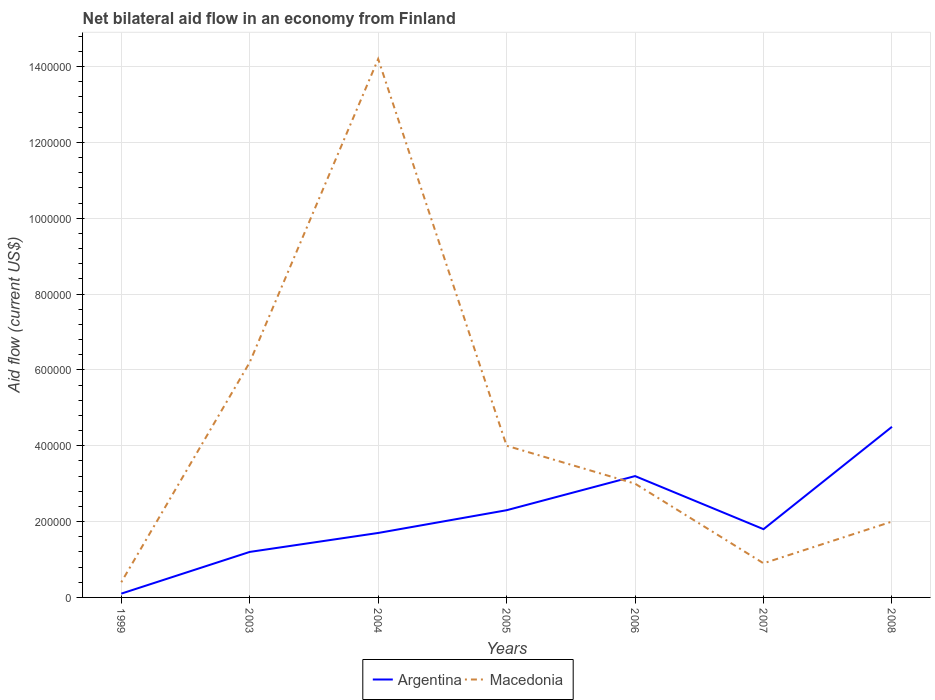How many different coloured lines are there?
Provide a succinct answer. 2. What is the total net bilateral aid flow in Argentina in the graph?
Provide a short and direct response. -3.10e+05. How many years are there in the graph?
Offer a very short reply. 7. Are the values on the major ticks of Y-axis written in scientific E-notation?
Provide a succinct answer. No. How many legend labels are there?
Offer a terse response. 2. What is the title of the graph?
Give a very brief answer. Net bilateral aid flow in an economy from Finland. What is the Aid flow (current US$) in Argentina in 1999?
Make the answer very short. 10000. What is the Aid flow (current US$) in Macedonia in 2003?
Offer a very short reply. 6.20e+05. What is the Aid flow (current US$) in Argentina in 2004?
Give a very brief answer. 1.70e+05. What is the Aid flow (current US$) in Macedonia in 2004?
Provide a short and direct response. 1.42e+06. What is the Aid flow (current US$) in Argentina in 2006?
Offer a very short reply. 3.20e+05. What is the Aid flow (current US$) of Macedonia in 2006?
Ensure brevity in your answer.  3.00e+05. What is the Aid flow (current US$) of Argentina in 2008?
Keep it short and to the point. 4.50e+05. What is the Aid flow (current US$) of Macedonia in 2008?
Provide a succinct answer. 2.00e+05. Across all years, what is the maximum Aid flow (current US$) in Macedonia?
Ensure brevity in your answer.  1.42e+06. Across all years, what is the minimum Aid flow (current US$) in Macedonia?
Keep it short and to the point. 4.00e+04. What is the total Aid flow (current US$) in Argentina in the graph?
Your answer should be compact. 1.48e+06. What is the total Aid flow (current US$) in Macedonia in the graph?
Give a very brief answer. 3.07e+06. What is the difference between the Aid flow (current US$) in Argentina in 1999 and that in 2003?
Provide a succinct answer. -1.10e+05. What is the difference between the Aid flow (current US$) in Macedonia in 1999 and that in 2003?
Provide a succinct answer. -5.80e+05. What is the difference between the Aid flow (current US$) of Argentina in 1999 and that in 2004?
Provide a short and direct response. -1.60e+05. What is the difference between the Aid flow (current US$) in Macedonia in 1999 and that in 2004?
Keep it short and to the point. -1.38e+06. What is the difference between the Aid flow (current US$) in Macedonia in 1999 and that in 2005?
Offer a terse response. -3.60e+05. What is the difference between the Aid flow (current US$) of Argentina in 1999 and that in 2006?
Your response must be concise. -3.10e+05. What is the difference between the Aid flow (current US$) in Macedonia in 1999 and that in 2007?
Give a very brief answer. -5.00e+04. What is the difference between the Aid flow (current US$) in Argentina in 1999 and that in 2008?
Give a very brief answer. -4.40e+05. What is the difference between the Aid flow (current US$) in Argentina in 2003 and that in 2004?
Keep it short and to the point. -5.00e+04. What is the difference between the Aid flow (current US$) of Macedonia in 2003 and that in 2004?
Give a very brief answer. -8.00e+05. What is the difference between the Aid flow (current US$) of Argentina in 2003 and that in 2005?
Provide a succinct answer. -1.10e+05. What is the difference between the Aid flow (current US$) of Macedonia in 2003 and that in 2005?
Ensure brevity in your answer.  2.20e+05. What is the difference between the Aid flow (current US$) of Argentina in 2003 and that in 2006?
Give a very brief answer. -2.00e+05. What is the difference between the Aid flow (current US$) of Macedonia in 2003 and that in 2006?
Offer a terse response. 3.20e+05. What is the difference between the Aid flow (current US$) in Macedonia in 2003 and that in 2007?
Your answer should be compact. 5.30e+05. What is the difference between the Aid flow (current US$) of Argentina in 2003 and that in 2008?
Make the answer very short. -3.30e+05. What is the difference between the Aid flow (current US$) of Argentina in 2004 and that in 2005?
Provide a short and direct response. -6.00e+04. What is the difference between the Aid flow (current US$) of Macedonia in 2004 and that in 2005?
Give a very brief answer. 1.02e+06. What is the difference between the Aid flow (current US$) in Argentina in 2004 and that in 2006?
Your response must be concise. -1.50e+05. What is the difference between the Aid flow (current US$) in Macedonia in 2004 and that in 2006?
Give a very brief answer. 1.12e+06. What is the difference between the Aid flow (current US$) in Macedonia in 2004 and that in 2007?
Give a very brief answer. 1.33e+06. What is the difference between the Aid flow (current US$) in Argentina in 2004 and that in 2008?
Keep it short and to the point. -2.80e+05. What is the difference between the Aid flow (current US$) of Macedonia in 2004 and that in 2008?
Offer a terse response. 1.22e+06. What is the difference between the Aid flow (current US$) in Argentina in 2005 and that in 2006?
Offer a terse response. -9.00e+04. What is the difference between the Aid flow (current US$) of Macedonia in 2005 and that in 2006?
Ensure brevity in your answer.  1.00e+05. What is the difference between the Aid flow (current US$) in Argentina in 2005 and that in 2008?
Your response must be concise. -2.20e+05. What is the difference between the Aid flow (current US$) in Macedonia in 2006 and that in 2008?
Make the answer very short. 1.00e+05. What is the difference between the Aid flow (current US$) of Argentina in 2007 and that in 2008?
Give a very brief answer. -2.70e+05. What is the difference between the Aid flow (current US$) in Macedonia in 2007 and that in 2008?
Give a very brief answer. -1.10e+05. What is the difference between the Aid flow (current US$) in Argentina in 1999 and the Aid flow (current US$) in Macedonia in 2003?
Keep it short and to the point. -6.10e+05. What is the difference between the Aid flow (current US$) of Argentina in 1999 and the Aid flow (current US$) of Macedonia in 2004?
Give a very brief answer. -1.41e+06. What is the difference between the Aid flow (current US$) of Argentina in 1999 and the Aid flow (current US$) of Macedonia in 2005?
Make the answer very short. -3.90e+05. What is the difference between the Aid flow (current US$) of Argentina in 1999 and the Aid flow (current US$) of Macedonia in 2007?
Offer a terse response. -8.00e+04. What is the difference between the Aid flow (current US$) of Argentina in 2003 and the Aid flow (current US$) of Macedonia in 2004?
Give a very brief answer. -1.30e+06. What is the difference between the Aid flow (current US$) of Argentina in 2003 and the Aid flow (current US$) of Macedonia in 2005?
Offer a terse response. -2.80e+05. What is the difference between the Aid flow (current US$) in Argentina in 2003 and the Aid flow (current US$) in Macedonia in 2008?
Your answer should be very brief. -8.00e+04. What is the difference between the Aid flow (current US$) in Argentina in 2004 and the Aid flow (current US$) in Macedonia in 2005?
Keep it short and to the point. -2.30e+05. What is the difference between the Aid flow (current US$) of Argentina in 2004 and the Aid flow (current US$) of Macedonia in 2007?
Offer a very short reply. 8.00e+04. What is the difference between the Aid flow (current US$) of Argentina in 2005 and the Aid flow (current US$) of Macedonia in 2007?
Make the answer very short. 1.40e+05. What is the difference between the Aid flow (current US$) of Argentina in 2006 and the Aid flow (current US$) of Macedonia in 2008?
Give a very brief answer. 1.20e+05. What is the average Aid flow (current US$) in Argentina per year?
Make the answer very short. 2.11e+05. What is the average Aid flow (current US$) in Macedonia per year?
Give a very brief answer. 4.39e+05. In the year 1999, what is the difference between the Aid flow (current US$) of Argentina and Aid flow (current US$) of Macedonia?
Your answer should be compact. -3.00e+04. In the year 2003, what is the difference between the Aid flow (current US$) in Argentina and Aid flow (current US$) in Macedonia?
Make the answer very short. -5.00e+05. In the year 2004, what is the difference between the Aid flow (current US$) in Argentina and Aid flow (current US$) in Macedonia?
Offer a very short reply. -1.25e+06. In the year 2005, what is the difference between the Aid flow (current US$) of Argentina and Aid flow (current US$) of Macedonia?
Offer a very short reply. -1.70e+05. In the year 2006, what is the difference between the Aid flow (current US$) of Argentina and Aid flow (current US$) of Macedonia?
Your answer should be very brief. 2.00e+04. In the year 2008, what is the difference between the Aid flow (current US$) in Argentina and Aid flow (current US$) in Macedonia?
Provide a succinct answer. 2.50e+05. What is the ratio of the Aid flow (current US$) of Argentina in 1999 to that in 2003?
Your answer should be compact. 0.08. What is the ratio of the Aid flow (current US$) in Macedonia in 1999 to that in 2003?
Your answer should be compact. 0.06. What is the ratio of the Aid flow (current US$) of Argentina in 1999 to that in 2004?
Offer a terse response. 0.06. What is the ratio of the Aid flow (current US$) in Macedonia in 1999 to that in 2004?
Give a very brief answer. 0.03. What is the ratio of the Aid flow (current US$) of Argentina in 1999 to that in 2005?
Keep it short and to the point. 0.04. What is the ratio of the Aid flow (current US$) of Macedonia in 1999 to that in 2005?
Keep it short and to the point. 0.1. What is the ratio of the Aid flow (current US$) in Argentina in 1999 to that in 2006?
Keep it short and to the point. 0.03. What is the ratio of the Aid flow (current US$) of Macedonia in 1999 to that in 2006?
Ensure brevity in your answer.  0.13. What is the ratio of the Aid flow (current US$) of Argentina in 1999 to that in 2007?
Ensure brevity in your answer.  0.06. What is the ratio of the Aid flow (current US$) in Macedonia in 1999 to that in 2007?
Keep it short and to the point. 0.44. What is the ratio of the Aid flow (current US$) in Argentina in 1999 to that in 2008?
Your answer should be very brief. 0.02. What is the ratio of the Aid flow (current US$) of Argentina in 2003 to that in 2004?
Your response must be concise. 0.71. What is the ratio of the Aid flow (current US$) in Macedonia in 2003 to that in 2004?
Offer a terse response. 0.44. What is the ratio of the Aid flow (current US$) of Argentina in 2003 to that in 2005?
Provide a succinct answer. 0.52. What is the ratio of the Aid flow (current US$) in Macedonia in 2003 to that in 2005?
Provide a succinct answer. 1.55. What is the ratio of the Aid flow (current US$) in Macedonia in 2003 to that in 2006?
Provide a short and direct response. 2.07. What is the ratio of the Aid flow (current US$) of Macedonia in 2003 to that in 2007?
Your answer should be very brief. 6.89. What is the ratio of the Aid flow (current US$) of Argentina in 2003 to that in 2008?
Give a very brief answer. 0.27. What is the ratio of the Aid flow (current US$) in Macedonia in 2003 to that in 2008?
Your answer should be compact. 3.1. What is the ratio of the Aid flow (current US$) in Argentina in 2004 to that in 2005?
Give a very brief answer. 0.74. What is the ratio of the Aid flow (current US$) in Macedonia in 2004 to that in 2005?
Your answer should be compact. 3.55. What is the ratio of the Aid flow (current US$) of Argentina in 2004 to that in 2006?
Your response must be concise. 0.53. What is the ratio of the Aid flow (current US$) of Macedonia in 2004 to that in 2006?
Your response must be concise. 4.73. What is the ratio of the Aid flow (current US$) of Macedonia in 2004 to that in 2007?
Keep it short and to the point. 15.78. What is the ratio of the Aid flow (current US$) in Argentina in 2004 to that in 2008?
Your answer should be very brief. 0.38. What is the ratio of the Aid flow (current US$) in Argentina in 2005 to that in 2006?
Ensure brevity in your answer.  0.72. What is the ratio of the Aid flow (current US$) of Argentina in 2005 to that in 2007?
Offer a terse response. 1.28. What is the ratio of the Aid flow (current US$) of Macedonia in 2005 to that in 2007?
Keep it short and to the point. 4.44. What is the ratio of the Aid flow (current US$) in Argentina in 2005 to that in 2008?
Ensure brevity in your answer.  0.51. What is the ratio of the Aid flow (current US$) of Macedonia in 2005 to that in 2008?
Provide a short and direct response. 2. What is the ratio of the Aid flow (current US$) of Argentina in 2006 to that in 2007?
Keep it short and to the point. 1.78. What is the ratio of the Aid flow (current US$) in Argentina in 2006 to that in 2008?
Your answer should be very brief. 0.71. What is the ratio of the Aid flow (current US$) of Macedonia in 2006 to that in 2008?
Provide a succinct answer. 1.5. What is the ratio of the Aid flow (current US$) in Macedonia in 2007 to that in 2008?
Your response must be concise. 0.45. What is the difference between the highest and the second highest Aid flow (current US$) of Macedonia?
Offer a very short reply. 8.00e+05. What is the difference between the highest and the lowest Aid flow (current US$) in Argentina?
Keep it short and to the point. 4.40e+05. What is the difference between the highest and the lowest Aid flow (current US$) of Macedonia?
Keep it short and to the point. 1.38e+06. 